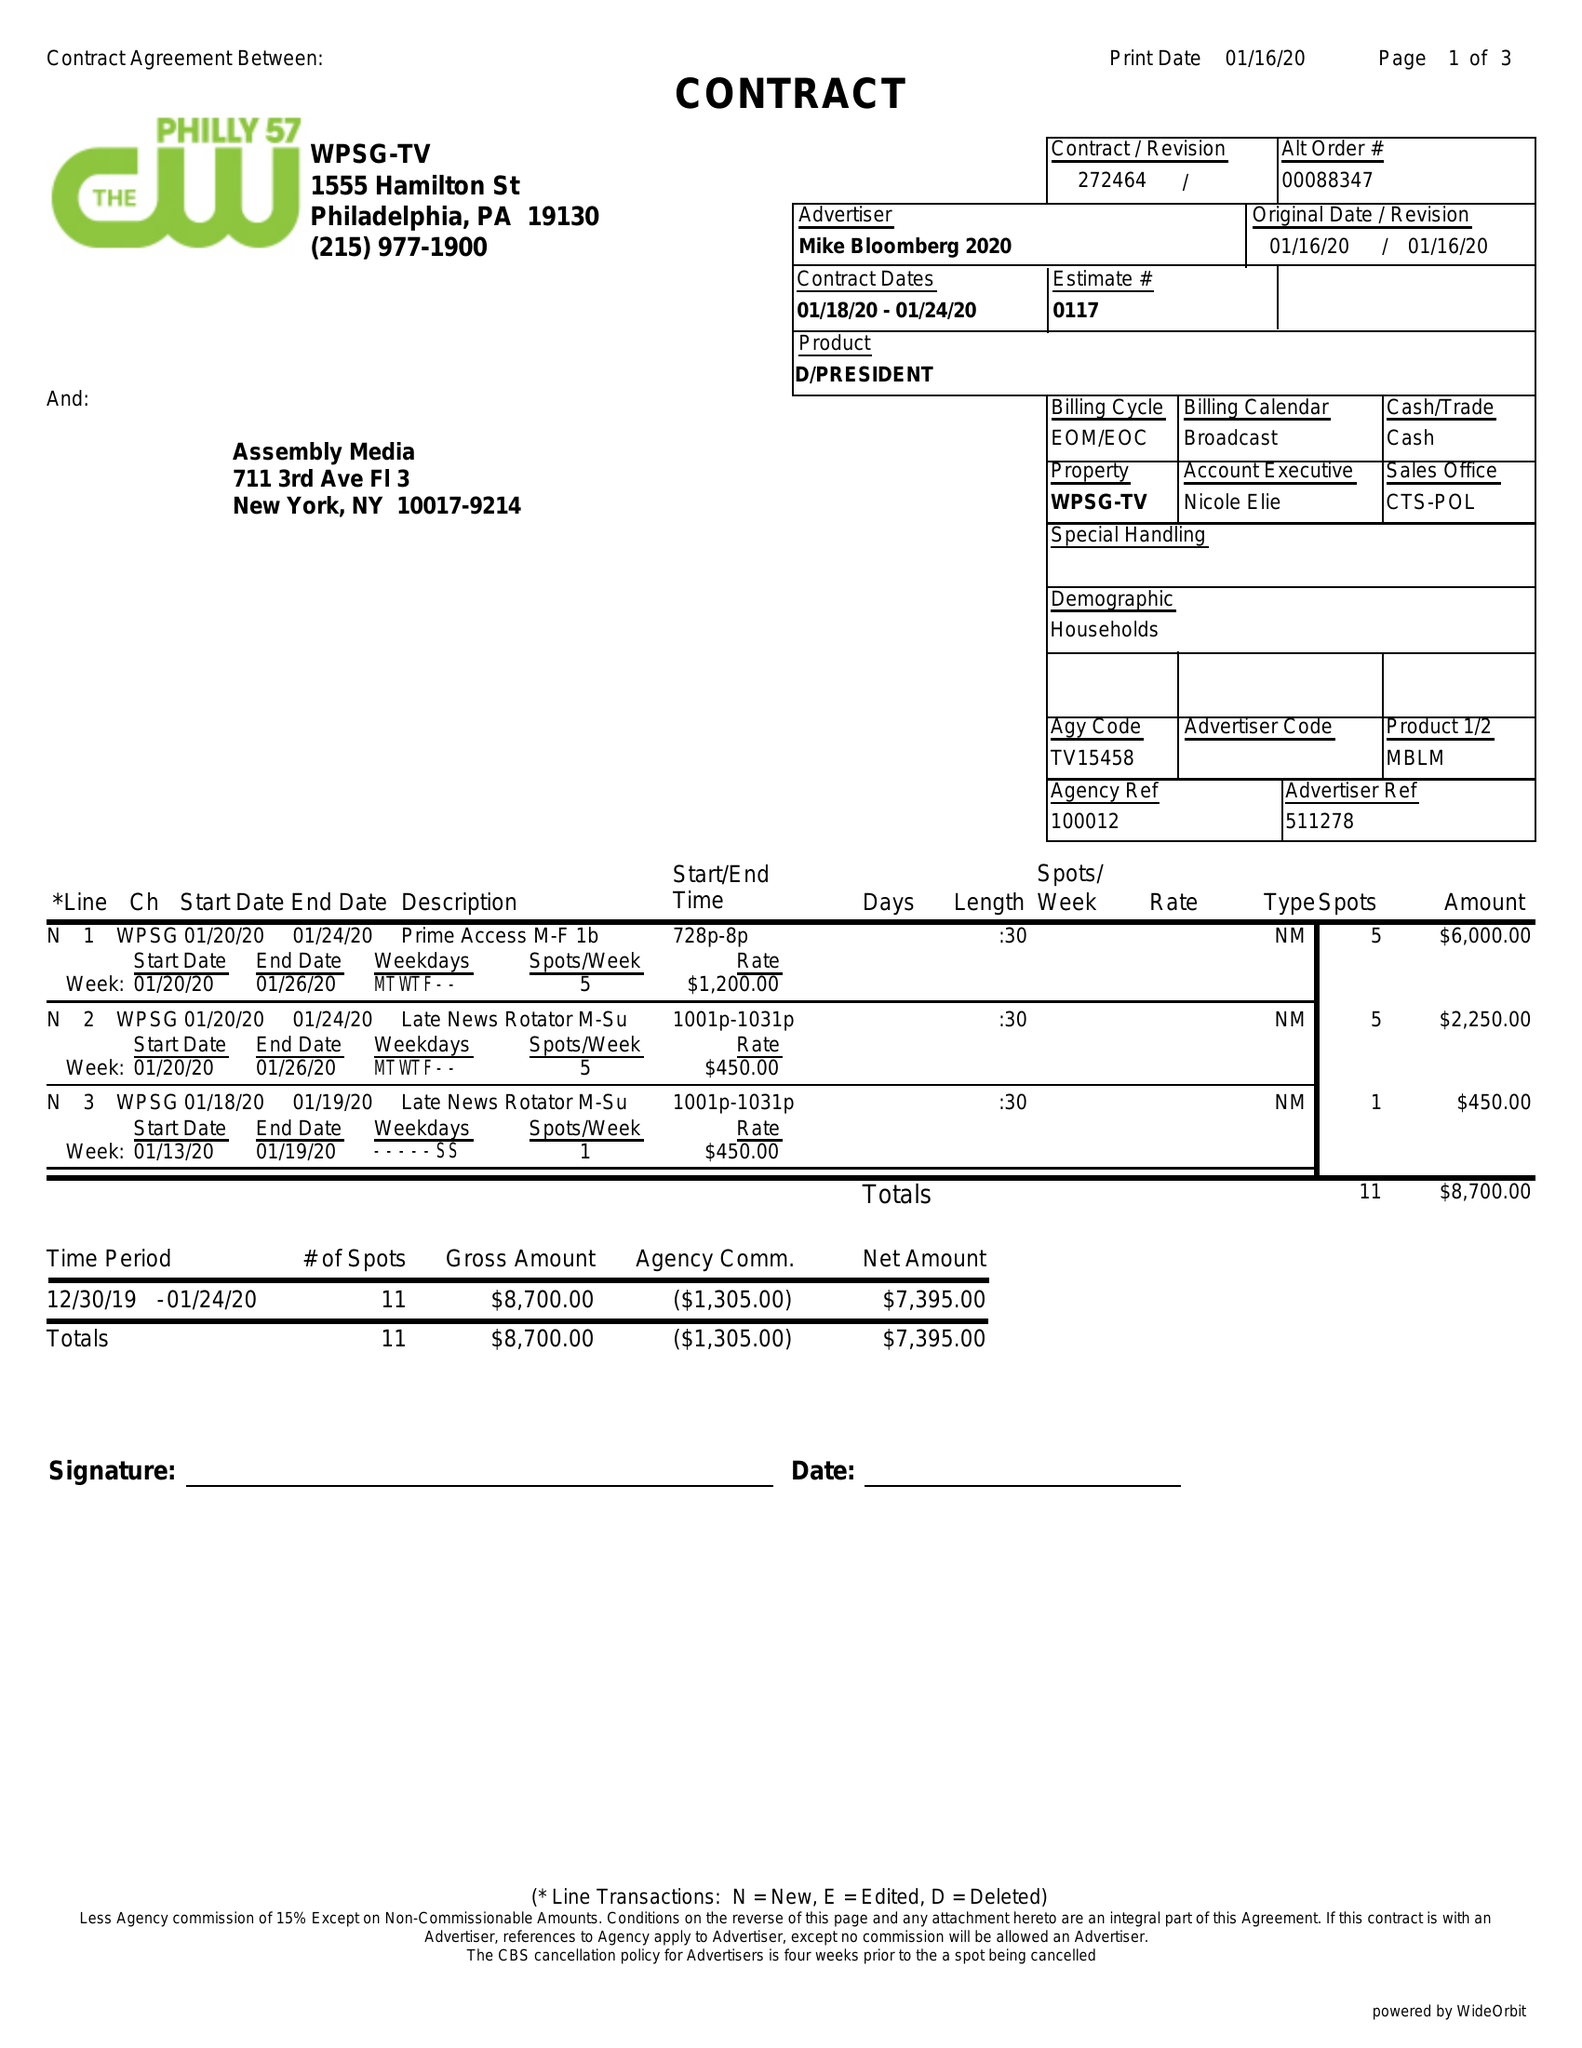What is the value for the advertiser?
Answer the question using a single word or phrase. MIKE BLOOMBERG 2020 